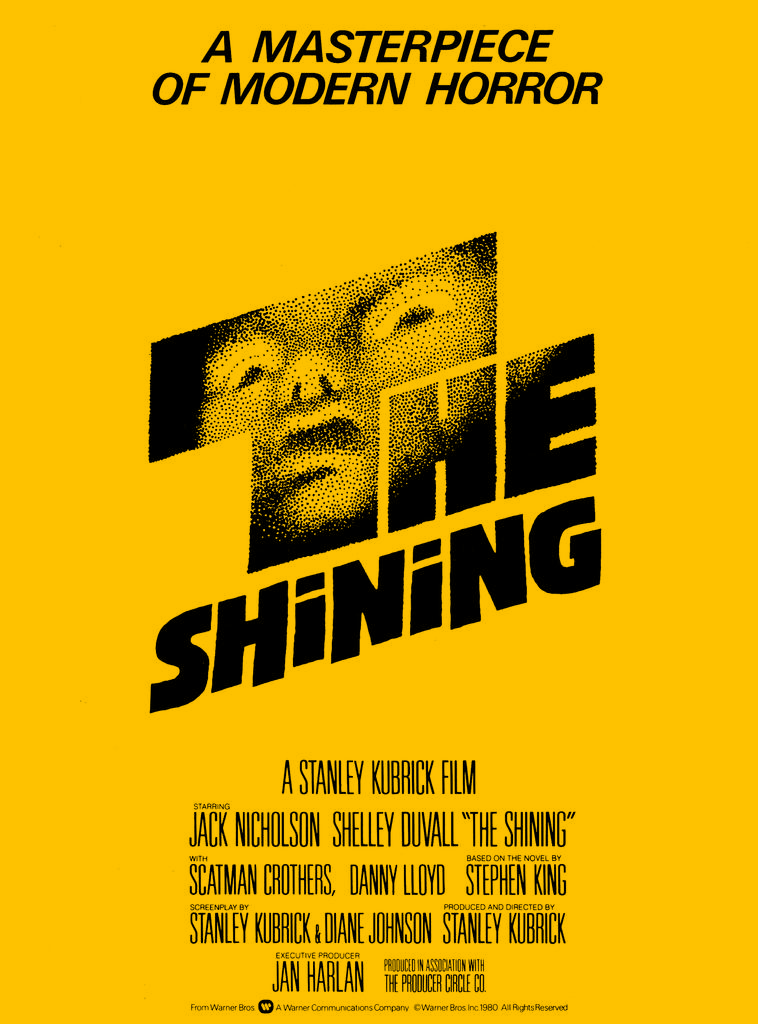What is the color of the poster in the image? The poster in the image is yellow. What color is the text on the poster? The text on the poster is written in black color. Can you describe any other elements in the image besides the poster? Yes, there is a person's face visible in the image. How does the person in the image kick the drawer? There is no drawer or kicking action present in the image. 